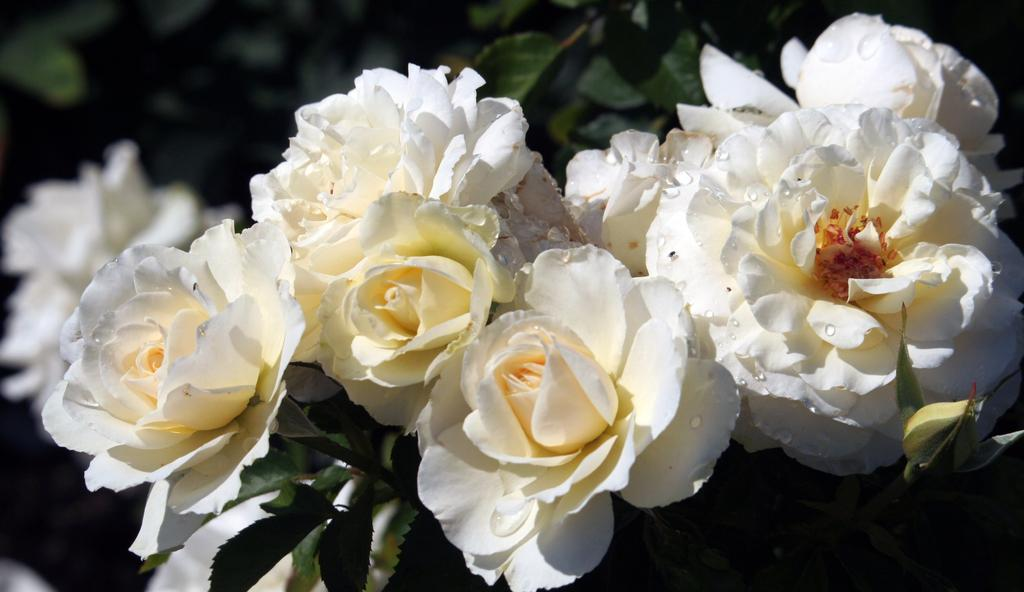What type of plant life is present in the image? There are flowers, buds, and leaves in the image. Can you describe the stage of growth for the plants in the image? The plants in the image have both buds and flowers, indicating various stages of growth. What is the condition of the background in the image? The background of the image is blurry. Can you tell me how many jewels are attached to the flowers in the image? There are no jewels present on the flowers in the image. What type of seat can be seen in the image? There is no seat present in the image; it features flowers, buds, and leaves. 